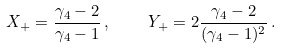Convert formula to latex. <formula><loc_0><loc_0><loc_500><loc_500>X _ { + } = \frac { \gamma _ { 4 } - 2 } { \gamma _ { 4 } - 1 } \, , \quad Y _ { + } = 2 \frac { \gamma _ { 4 } - 2 } { ( \gamma _ { 4 } - 1 ) ^ { 2 } } \, .</formula> 